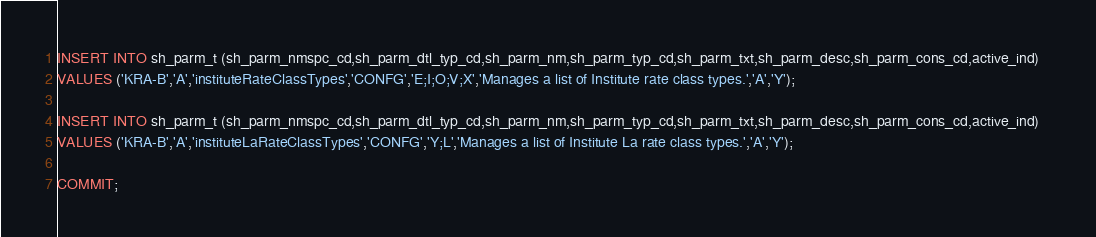<code> <loc_0><loc_0><loc_500><loc_500><_SQL_>INSERT INTO sh_parm_t (sh_parm_nmspc_cd,sh_parm_dtl_typ_cd,sh_parm_nm,sh_parm_typ_cd,sh_parm_txt,sh_parm_desc,sh_parm_cons_cd,active_ind)   
VALUES ('KRA-B','A','instituteRateClassTypes','CONFG','E;I;O;V;X','Manages a list of Institute rate class types.','A','Y');

INSERT INTO sh_parm_t (sh_parm_nmspc_cd,sh_parm_dtl_typ_cd,sh_parm_nm,sh_parm_typ_cd,sh_parm_txt,sh_parm_desc,sh_parm_cons_cd,active_ind)  
VALUES ('KRA-B','A','instituteLaRateClassTypes','CONFG','Y;L','Manages a list of Institute La rate class types.','A','Y');

COMMIT;</code> 